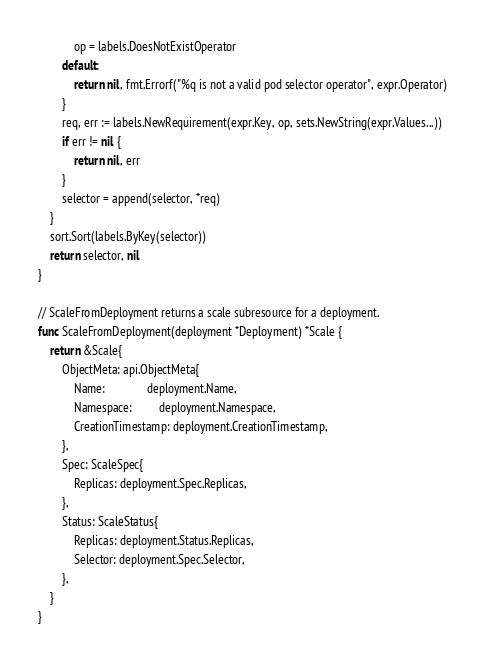<code> <loc_0><loc_0><loc_500><loc_500><_Go_>			op = labels.DoesNotExistOperator
		default:
			return nil, fmt.Errorf("%q is not a valid pod selector operator", expr.Operator)
		}
		req, err := labels.NewRequirement(expr.Key, op, sets.NewString(expr.Values...))
		if err != nil {
			return nil, err
		}
		selector = append(selector, *req)
	}
	sort.Sort(labels.ByKey(selector))
	return selector, nil
}

// ScaleFromDeployment returns a scale subresource for a deployment.
func ScaleFromDeployment(deployment *Deployment) *Scale {
	return &Scale{
		ObjectMeta: api.ObjectMeta{
			Name:              deployment.Name,
			Namespace:         deployment.Namespace,
			CreationTimestamp: deployment.CreationTimestamp,
		},
		Spec: ScaleSpec{
			Replicas: deployment.Spec.Replicas,
		},
		Status: ScaleStatus{
			Replicas: deployment.Status.Replicas,
			Selector: deployment.Spec.Selector,
		},
	}
}
</code> 